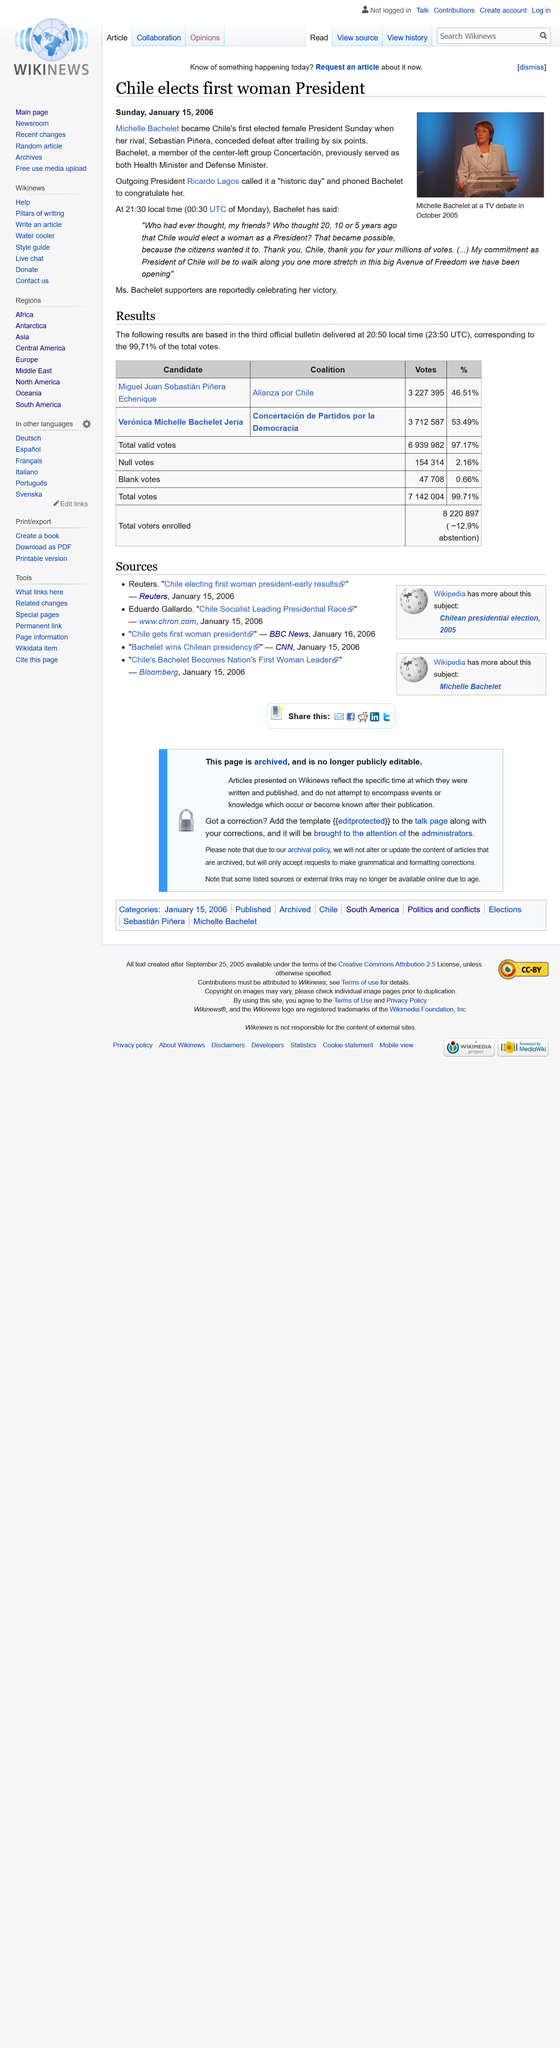List a handful of essential elements in this visual. The first female President of Chile was elected in the year 2006. Outgoing President Ricardo Lagos congratulated the first elected female President by phoning her to express his joy and congratulations. Michelle Bachelet was the first woman president in Chile. 